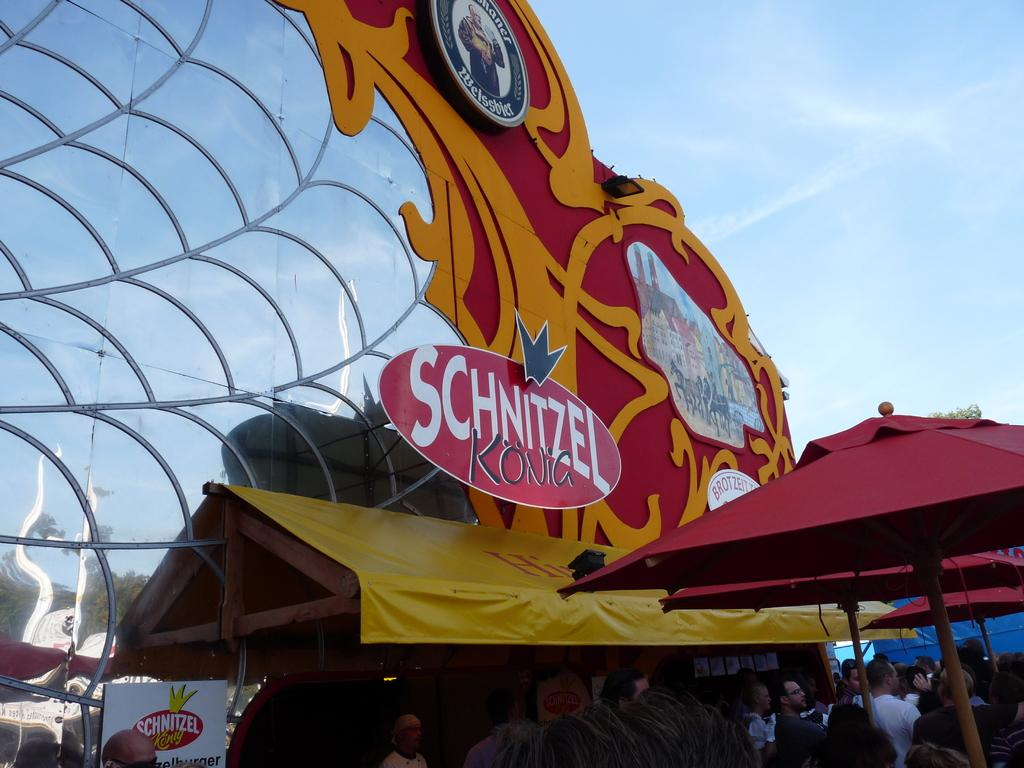Provide a one-sentence caption for the provided image. A Fair is packed and a line of people are at the Schnitzel Kona. 